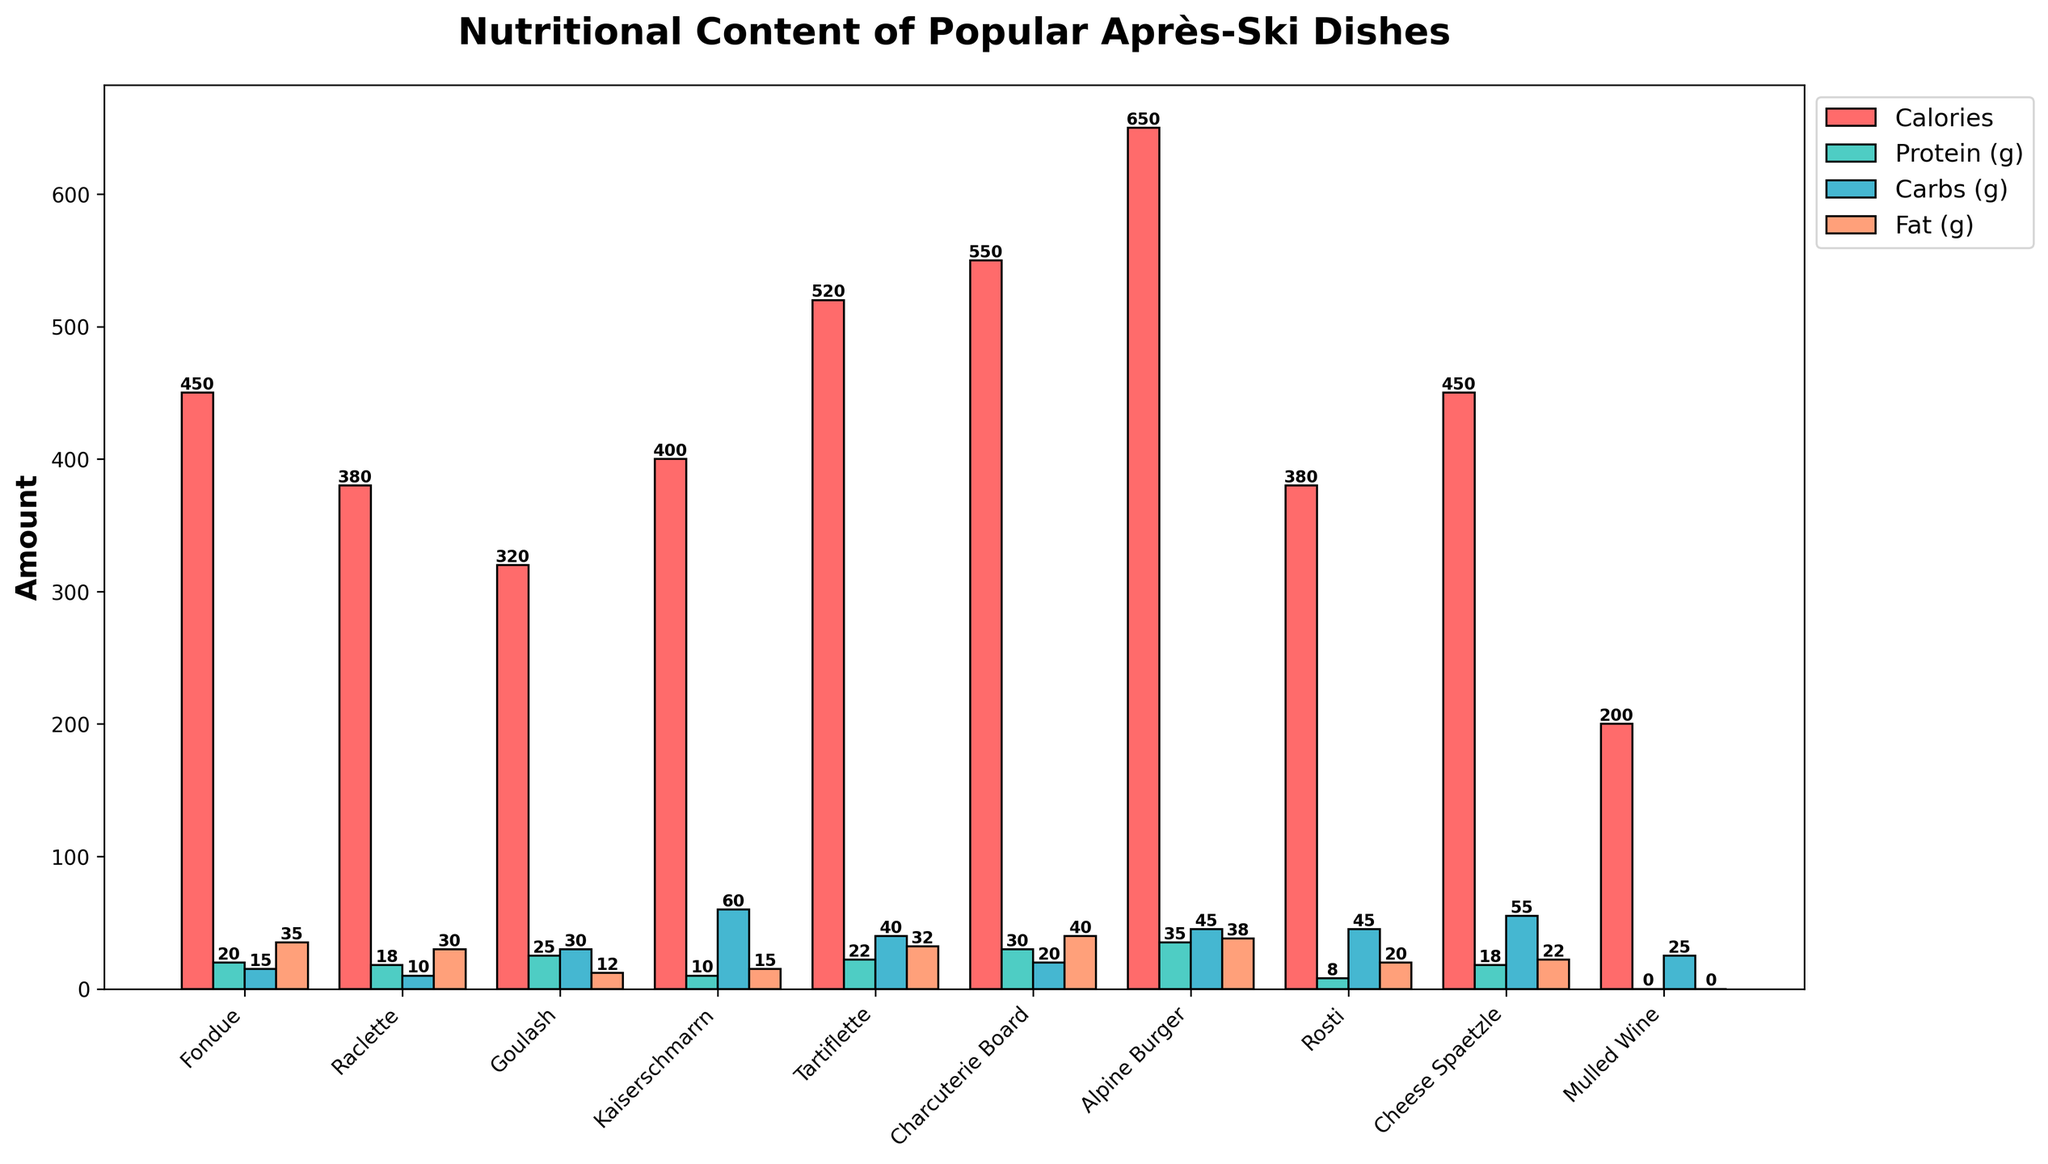Which dish has the highest calorie content? Look for the tallest red bar, representing calories. The tallest red bar corresponds to the "Alpine Burger".
Answer: Alpine Burger Which dish has the least amount of protein? Check the height of the green bars labeled "Protein (g)". The shortest green bar corresponds to "Mulled Wine".
Answer: Mulled Wine How much more fat does the Charcuterie Board have compared to Rosti? Identify the heights of the orange bars for each dish. The Charcuterie Board has a fat content of 40g, and Rosti has 20g. The difference is 40 - 20.
Answer: 20g What is the average carbohydrate content of the Fondue, Raclette, and Kaiserschmarrn? Add the carbohydrate content of Fondue (15g), Raclette (10g), and Kaiserschmarrn (60g), then divide by 3. (15 + 10 + 60) / 3 = 28.33.
Answer: 28.33g Which dish has the highest protein content? Look for the tallest green bar. The tallest green bar corresponds to the "Alpine Burger".
Answer: Alpine Burger Does the Goulash have more carbs or protein? Compare the heights of the green and blue bars for Goulash. The values are 30g for carbs and 25g for protein, so Goulash has more carbs.
Answer: Carbs Which dish has the second-highest fat content? After identifying the dish with the highest fat content (Alpine Burger, 38g), find the next tallest orange bar. The next tallest bar corresponds to the "Charcuterie Board" with 40g.
Answer: Charcuterie Board What is the total nutritional content (sum of calories, protein, carbs, and fat) of Cheese Spaetzle? Sum the values for Cheese Spaetzle: 450 (calories) + 18 (protein) + 55 (carbs) + 22 (fat) = 545.
Answer: 545 Rank the dishes based on their calorie content from highest to lowest. Compare the heights of the red bars for each dish and list them in descending order: Alpine Burger (650), Charcuterie Board (550), Tartiflette (520), Fondue (450), Cheese Spaetzle (450), Kaiserschmarrn (400), Raclette (380), Rosti (380), Goulash (320), Mulled Wine (200).
Answer: Alpine Burger, Charcuterie Board, Tartiflette, Fondue, Cheese Spaetzle, Kaiserschmarrn, Raclette, Rosti, Goulash, Mulled Wine 